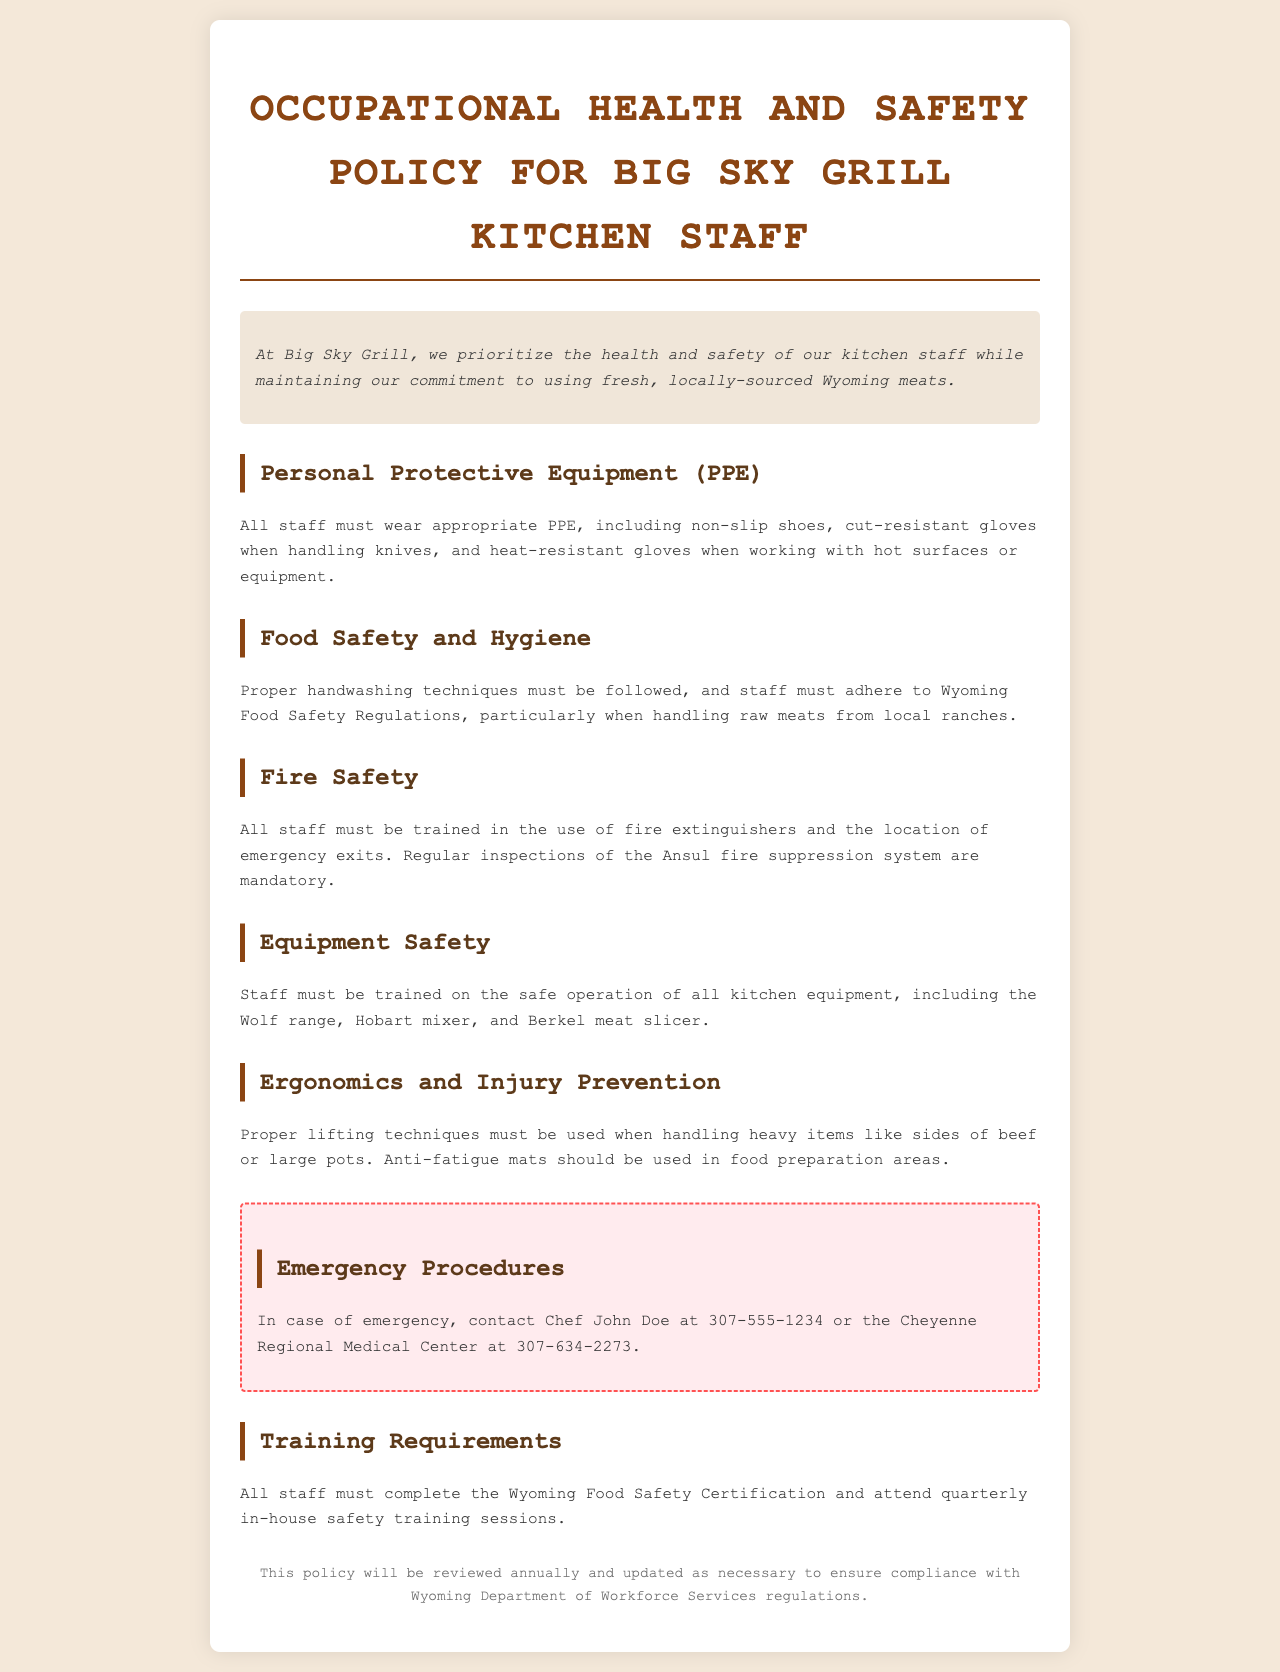What protective equipment must staff wear? The document states that all staff must wear appropriate PPE, which includes non-slip shoes, cut-resistant gloves when handling knives, and heat-resistant gloves when working with hot surfaces or equipment.
Answer: non-slip shoes, cut-resistant gloves, heat-resistant gloves Who should be contacted in case of an emergency? The policy provides an emergency contact number for Chef John Doe, which is mentioned in the emergency procedures section.
Answer: Chef John Doe What certification must all staff complete? The document specifies that staff must complete the Wyoming Food Safety Certification as part of their training requirements.
Answer: Wyoming Food Safety Certification What is included in the fire safety training? According to the document, staff must be trained in the use of fire extinguishers and the location of emergency exits.
Answer: fire extinguishers and emergency exits How often are safety training sessions held? The document states that staff must attend quarterly in-house safety training sessions.
Answer: quarterly Which kitchen equipment requires safe operation training? The policy mentions that staff must be trained on the safe operation of the Wolf range, Hobart mixer, and Berkel meat slicer.
Answer: Wolf range, Hobart mixer, Berkel meat slicer What must be used to prevent fatigue in food preparation areas? The document states that anti-fatigue mats should be used in food preparation areas to help with ergonomics and injury prevention.
Answer: anti-fatigue mats When is the policy reviewed? The footer of the document indicates that this policy will be reviewed annually and updated as necessary.
Answer: annually 